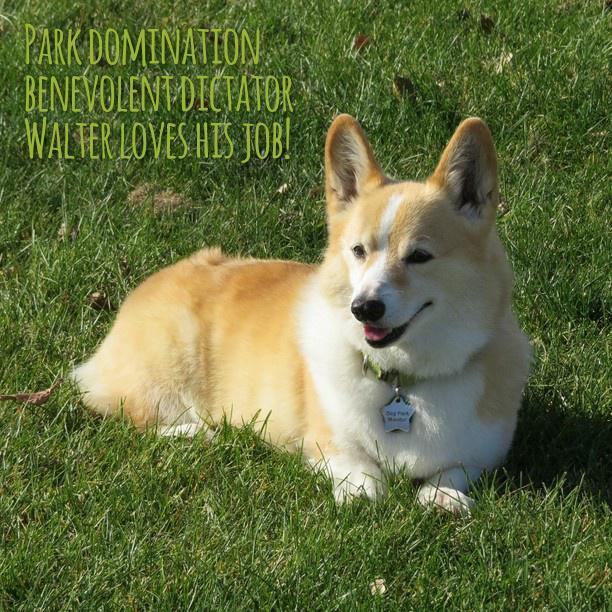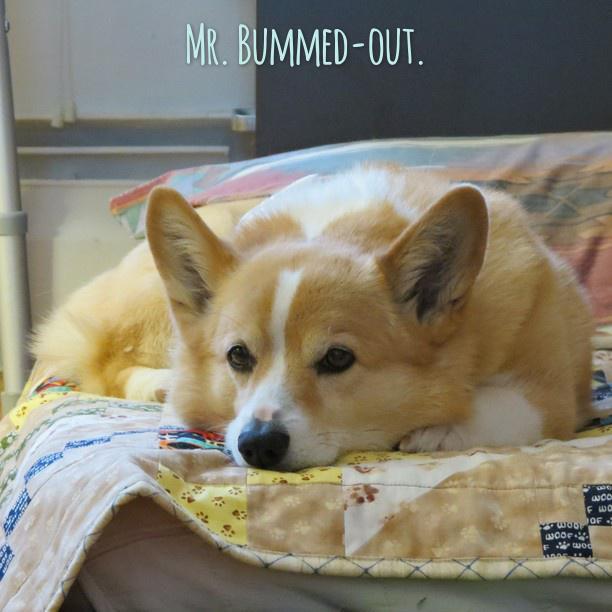The first image is the image on the left, the second image is the image on the right. Assess this claim about the two images: "The dog in the left photo has a star shapped tag hanging from its collar.". Correct or not? Answer yes or no. Yes. The first image is the image on the left, the second image is the image on the right. Analyze the images presented: Is the assertion "One image features a dog wearing a collar with a star-shaped tag." valid? Answer yes or no. Yes. 